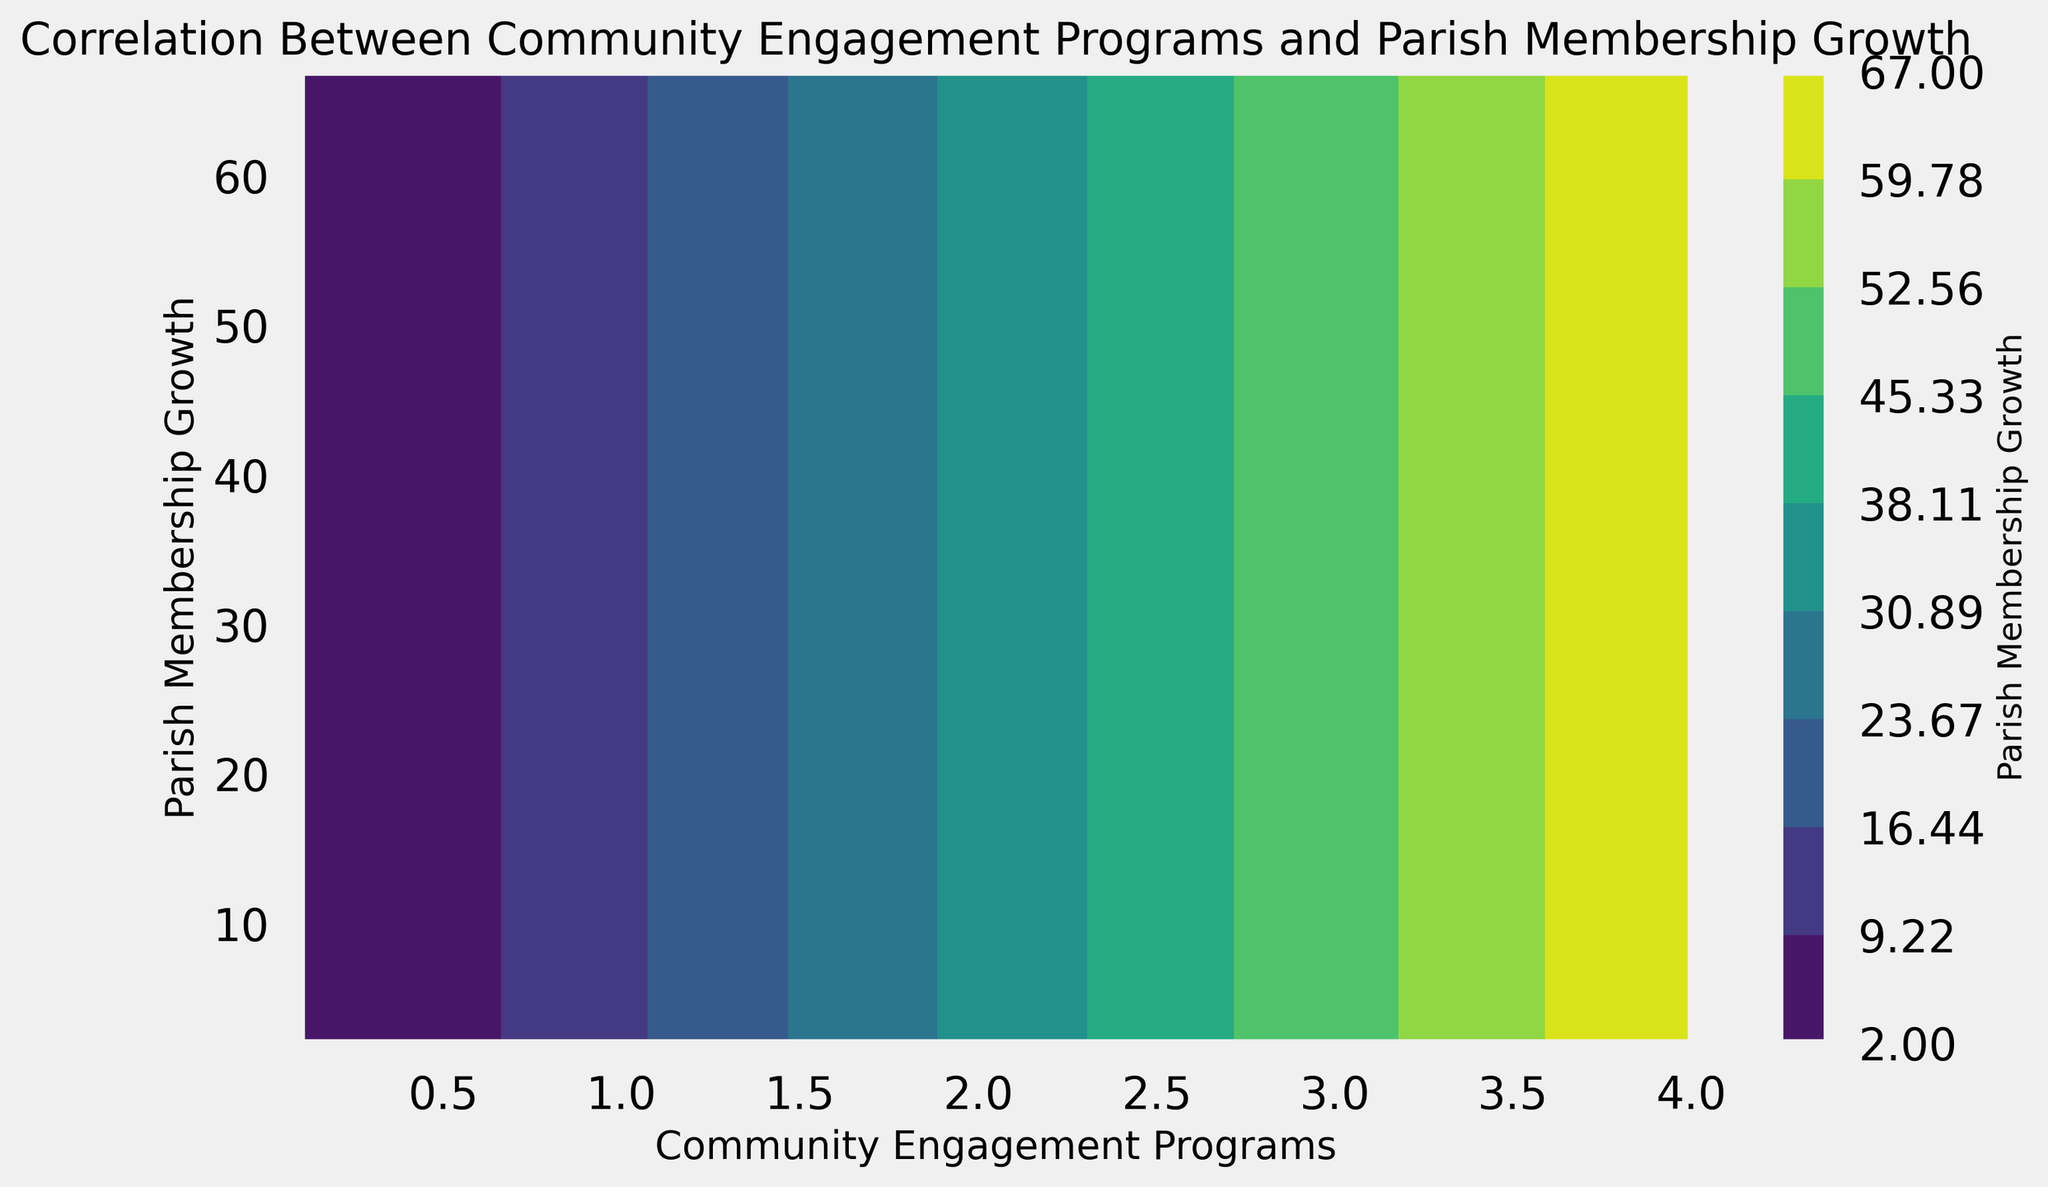What is the maximum value of Parish Membership Growth shown on the contour plot? To find the maximum value on the contour plot, we look at the highest point on the color gradient bar which represents Parish Membership Growth. The top value indicated on the bar is the maximum value.
Answer: 67 What is the general trend observed between Community Engagement Programs and Parish Membership Growth? By examining the contour plot, we notice that as Community Engagement Programs increase, Parish Membership Growth also tends to increase, indicating a positive correlation between the two.
Answer: Positive correlation What is the range for Community Engagement Programs that corresponds to Parish Membership Growth of 30? First, locate the region on the y-axis where Parish Membership Growth is 30. Then, trace horizontally to find the range of Community Engagement values this corresponds to. It’s around 1.8 on the x-axis.
Answer: Around 1.8 Which region, dark green or light green, represents higher growth in Parish membership? By looking at the color gradient on the contour plot, darker colors generally represent lower values, and lighter colors represent higher values. Thus, light green represents higher Parish Membership Growth.
Answer: Light green If a parish increases its Community Engagement Programs to 3.0, what is the approximate Parish Membership Growth they might expect? Locate the point on the x-axis for Community Engagement of 3.0 and trace upward to intersect with the contours. Then, go horizontally to the y-axis to find the corresponding Parish Membership Growth. This value is around 50.
Answer: Around 50 How does the contour shape change as Community Engagement Programs increase from 0.1 to 4.0? Observing the contours from left (0.1) to right (4.0) on the x-axis, they generally move upward indicating an increase in Parish Membership Growth. The space between contours may also change, indicating varied rates of growth.
Answer: Upward trend What is the approximate Parish Membership Growth when Community Engagement Programs are at 2.0? Go to the x-axis at 2.0 and look vertically to find the point where it meets the contour lines. Then, trace horizontally to the y-axis to find the Parish Membership Growth. This value is around 33.
Answer: Around 33 What color represents the highest level of Parish Membership Growth in the contour plot? Typically, the highest value in a contour plot is represented by the brightest or lightest color. In this plot, the lightest color represents the highest Parish Membership Growth.
Answer: Lightest color If a parish has a Community Engagement Program level of 1.5, what is the expected range of Parish Membership Growth based on the contour plot? Locate 1.5 on the x-axis and look vertically to intersect the contours. The corresponding y-values range between approximately 24 and 26.
Answer: 24 - 26 